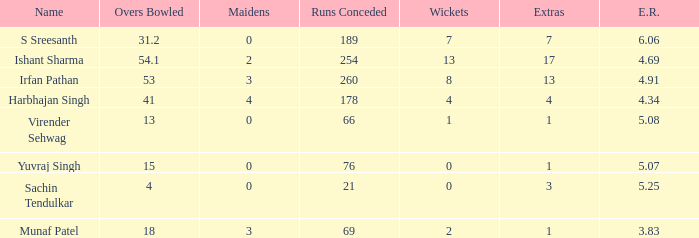Name the runs conceded where overs bowled is 53 1.0. 